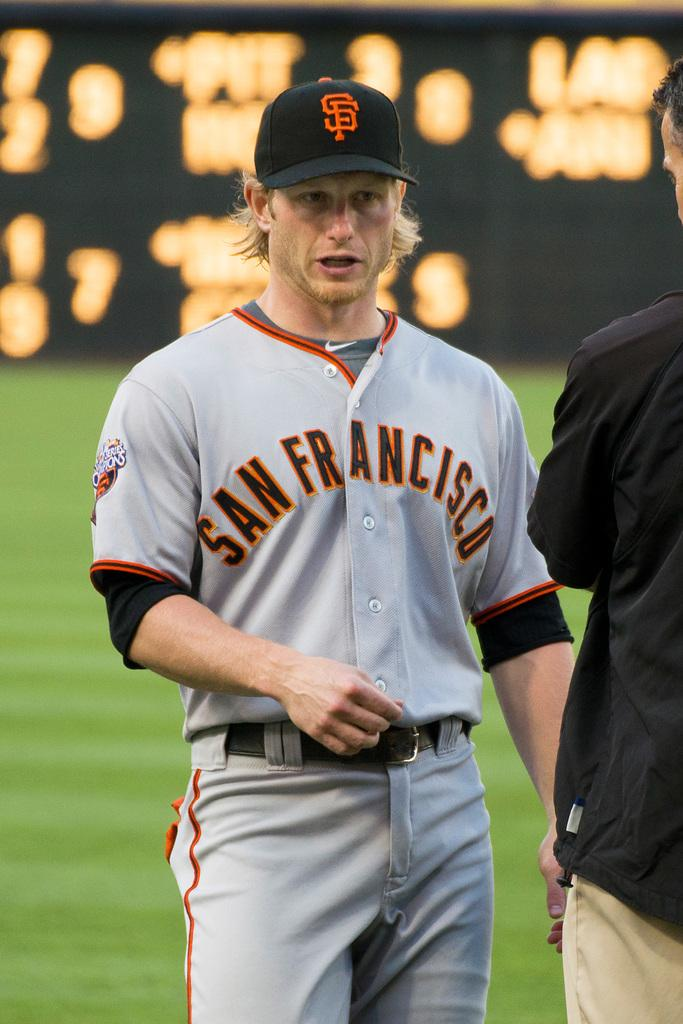<image>
Write a terse but informative summary of the picture. A man wears a San Francisco baseball uniform. 